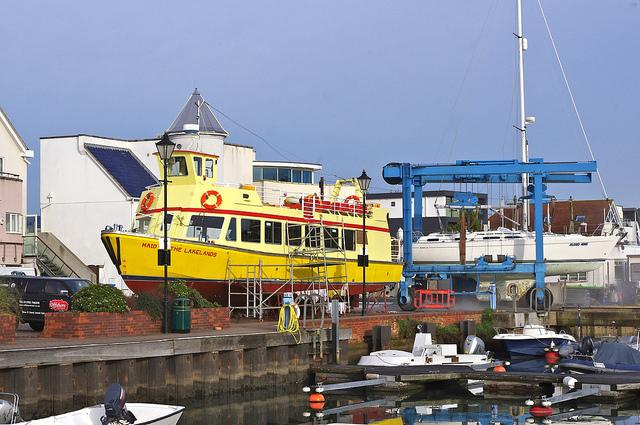What are the red planters on the left made from? bricks 